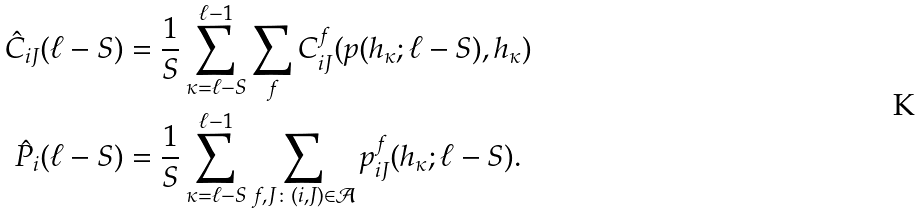Convert formula to latex. <formula><loc_0><loc_0><loc_500><loc_500>\hat { C } _ { i J } ( \ell - S ) & = \frac { 1 } { S } \sum _ { \kappa = \ell - S } ^ { \ell - 1 } \sum _ { f } C _ { i J } ^ { f } ( p ( h _ { \kappa } ; \ell - S ) , h _ { \kappa } ) \\ \hat { P } _ { i } ( \ell - S ) & = \frac { 1 } { S } \sum _ { \kappa = \ell - S } ^ { \ell - 1 } \sum _ { f , J \colon ( i , J ) \in \mathcal { A } } p _ { i J } ^ { f } ( h _ { \kappa } ; \ell - S ) .</formula> 